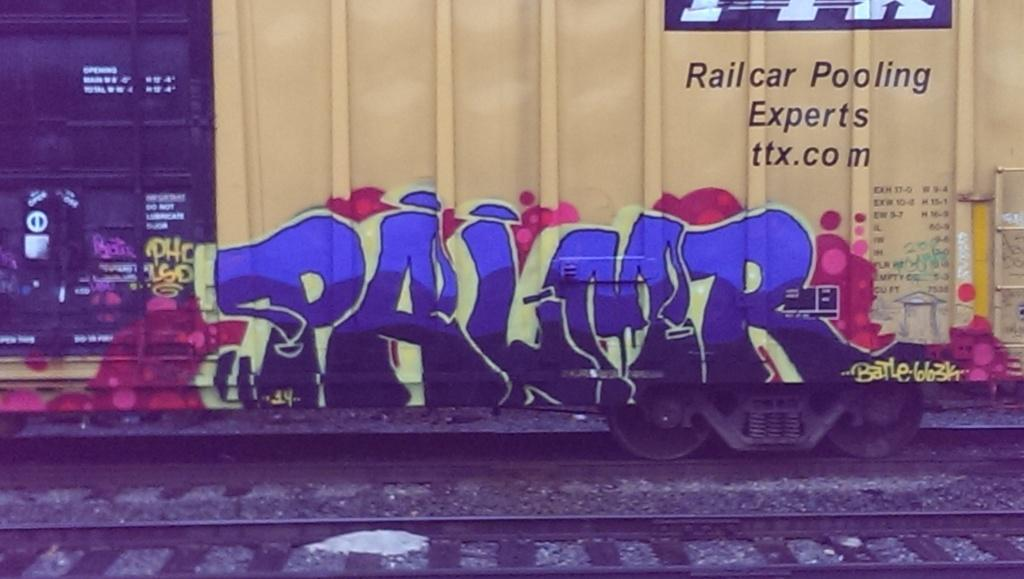Provide a one-sentence caption for the provided image. A train car with grafiti on it that says PALMR. 